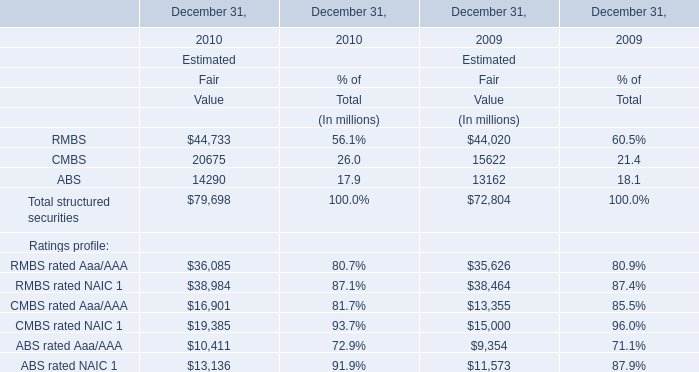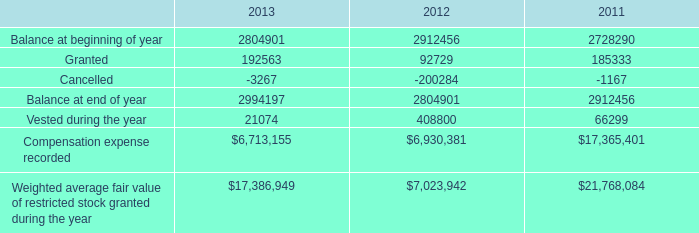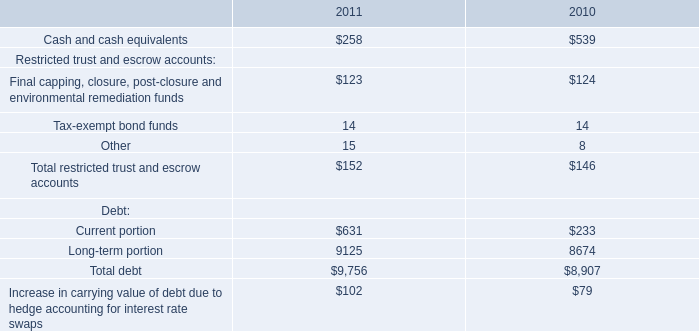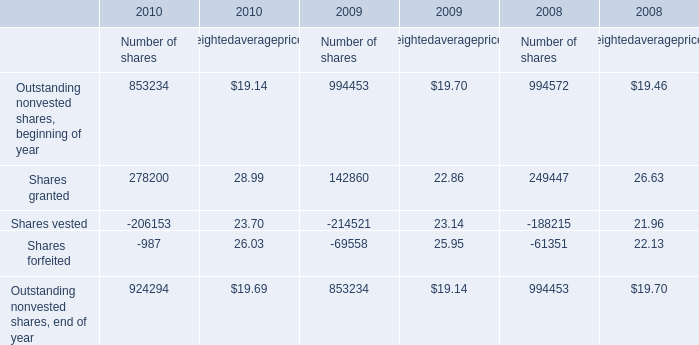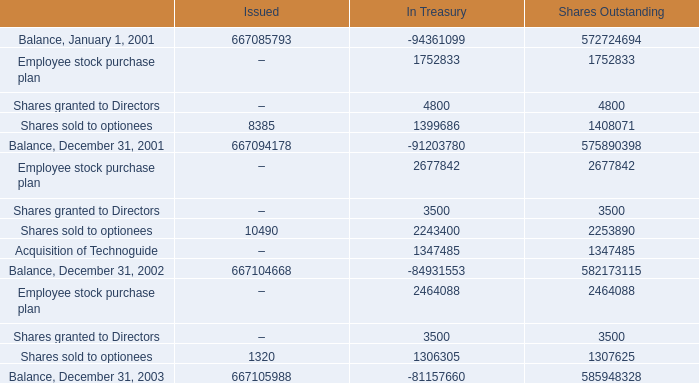What is the sum of Shares granted to Directors of Shares Outstanding, and Shares vested of 2010 Number of shares ? 
Computations: (3500.0 + 206153.0)
Answer: 209653.0. 